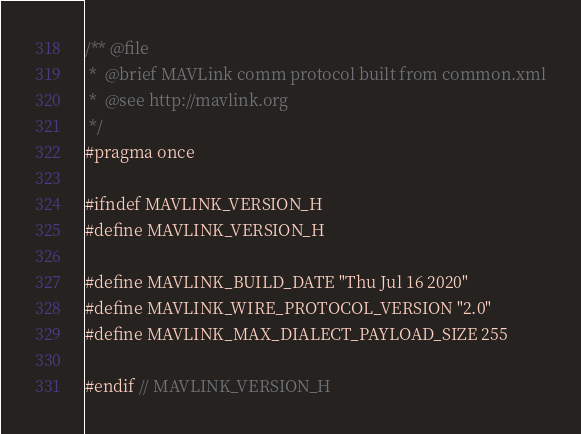Convert code to text. <code><loc_0><loc_0><loc_500><loc_500><_C_>/** @file
 *  @brief MAVLink comm protocol built from common.xml
 *  @see http://mavlink.org
 */
#pragma once
 
#ifndef MAVLINK_VERSION_H
#define MAVLINK_VERSION_H

#define MAVLINK_BUILD_DATE "Thu Jul 16 2020"
#define MAVLINK_WIRE_PROTOCOL_VERSION "2.0"
#define MAVLINK_MAX_DIALECT_PAYLOAD_SIZE 255
 
#endif // MAVLINK_VERSION_H
</code> 